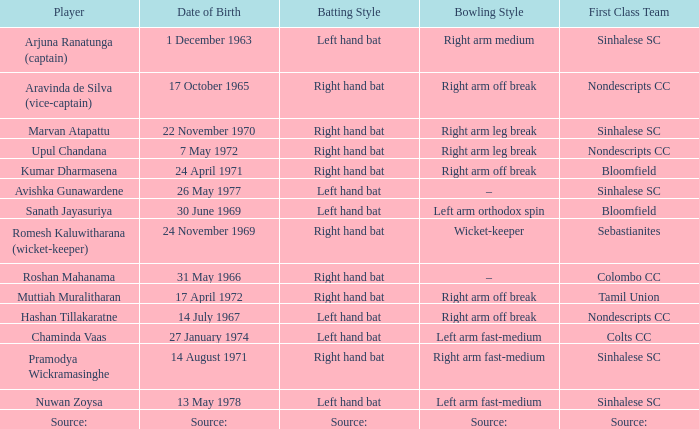When did avishka gunawardene come into the world? 26 May 1977. 